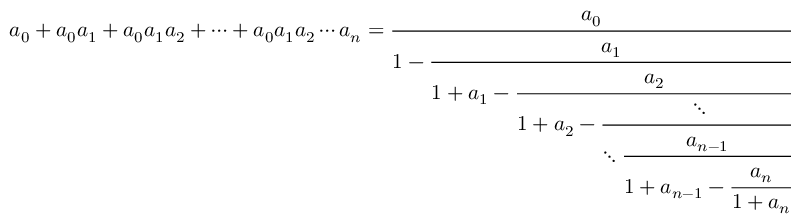<formula> <loc_0><loc_0><loc_500><loc_500>a _ { 0 } + a _ { 0 } a _ { 1 } + a _ { 0 } a _ { 1 } a _ { 2 } + \cdots + a _ { 0 } a _ { 1 } a _ { 2 } \cdots a _ { n } = { \cfrac { a _ { 0 } } { 1 - { \cfrac { a _ { 1 } } { 1 + a _ { 1 } - { \cfrac { a _ { 2 } } { 1 + a _ { 2 } - { \cfrac { \ddots } { \ddots { \cfrac { a _ { n - 1 } } { 1 + a _ { n - 1 } - { \cfrac { a _ { n } } { 1 + a _ { n } } } } } } } } } } } } }</formula> 